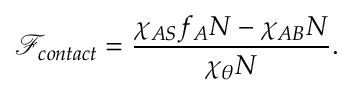<formula> <loc_0><loc_0><loc_500><loc_500>\mathcal { F } _ { c o n t a c t } = \frac { \chi _ { A S } f _ { A } N - \chi _ { A B } N } { \chi _ { \theta } N } .</formula> 